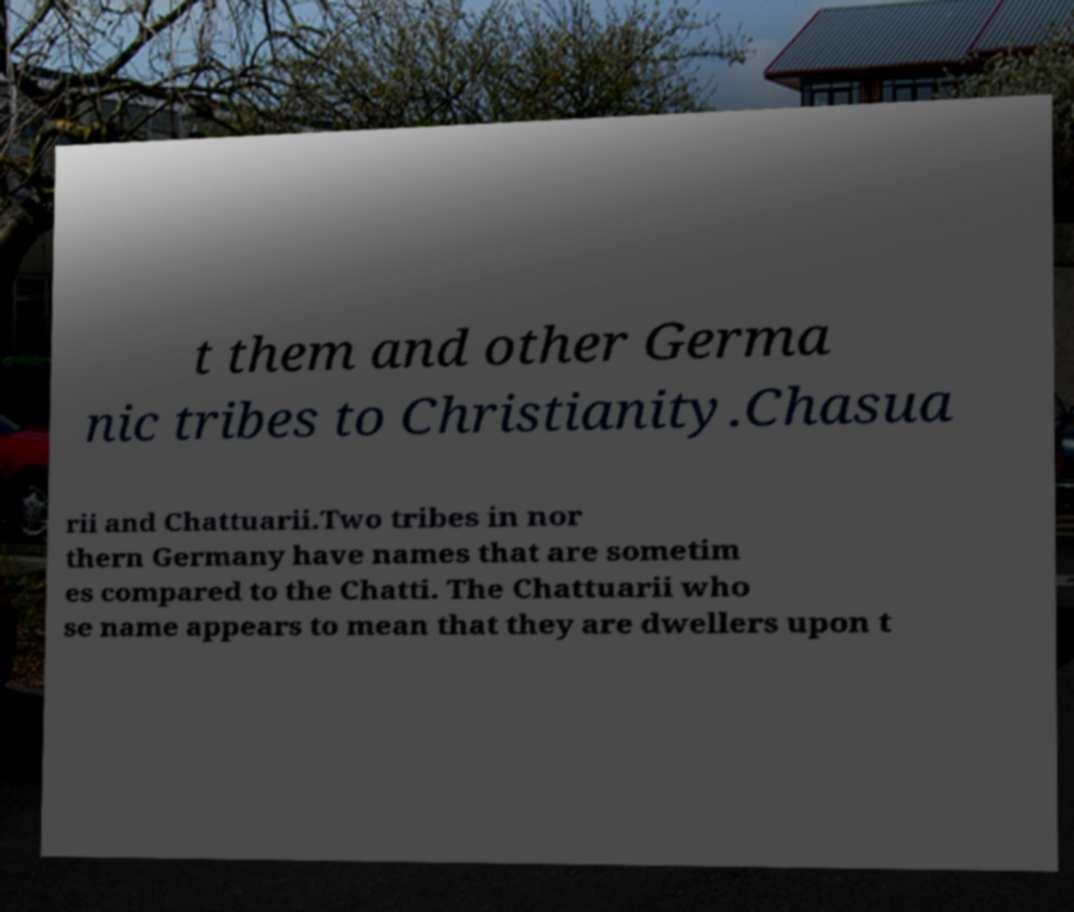Could you extract and type out the text from this image? t them and other Germa nic tribes to Christianity.Chasua rii and Chattuarii.Two tribes in nor thern Germany have names that are sometim es compared to the Chatti. The Chattuarii who se name appears to mean that they are dwellers upon t 